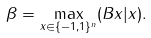<formula> <loc_0><loc_0><loc_500><loc_500>\beta = \max _ { x \in \{ - 1 , 1 \} ^ { n } } ( B x | x ) .</formula> 